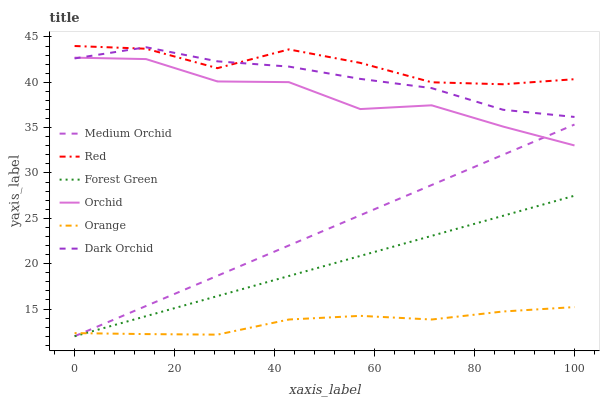Does Orange have the minimum area under the curve?
Answer yes or no. Yes. Does Red have the maximum area under the curve?
Answer yes or no. Yes. Does Dark Orchid have the minimum area under the curve?
Answer yes or no. No. Does Dark Orchid have the maximum area under the curve?
Answer yes or no. No. Is Forest Green the smoothest?
Answer yes or no. Yes. Is Orchid the roughest?
Answer yes or no. Yes. Is Dark Orchid the smoothest?
Answer yes or no. No. Is Dark Orchid the roughest?
Answer yes or no. No. Does Medium Orchid have the lowest value?
Answer yes or no. Yes. Does Dark Orchid have the lowest value?
Answer yes or no. No. Does Red have the highest value?
Answer yes or no. Yes. Does Dark Orchid have the highest value?
Answer yes or no. No. Is Forest Green less than Red?
Answer yes or no. Yes. Is Red greater than Orchid?
Answer yes or no. Yes. Does Dark Orchid intersect Orchid?
Answer yes or no. Yes. Is Dark Orchid less than Orchid?
Answer yes or no. No. Is Dark Orchid greater than Orchid?
Answer yes or no. No. Does Forest Green intersect Red?
Answer yes or no. No. 